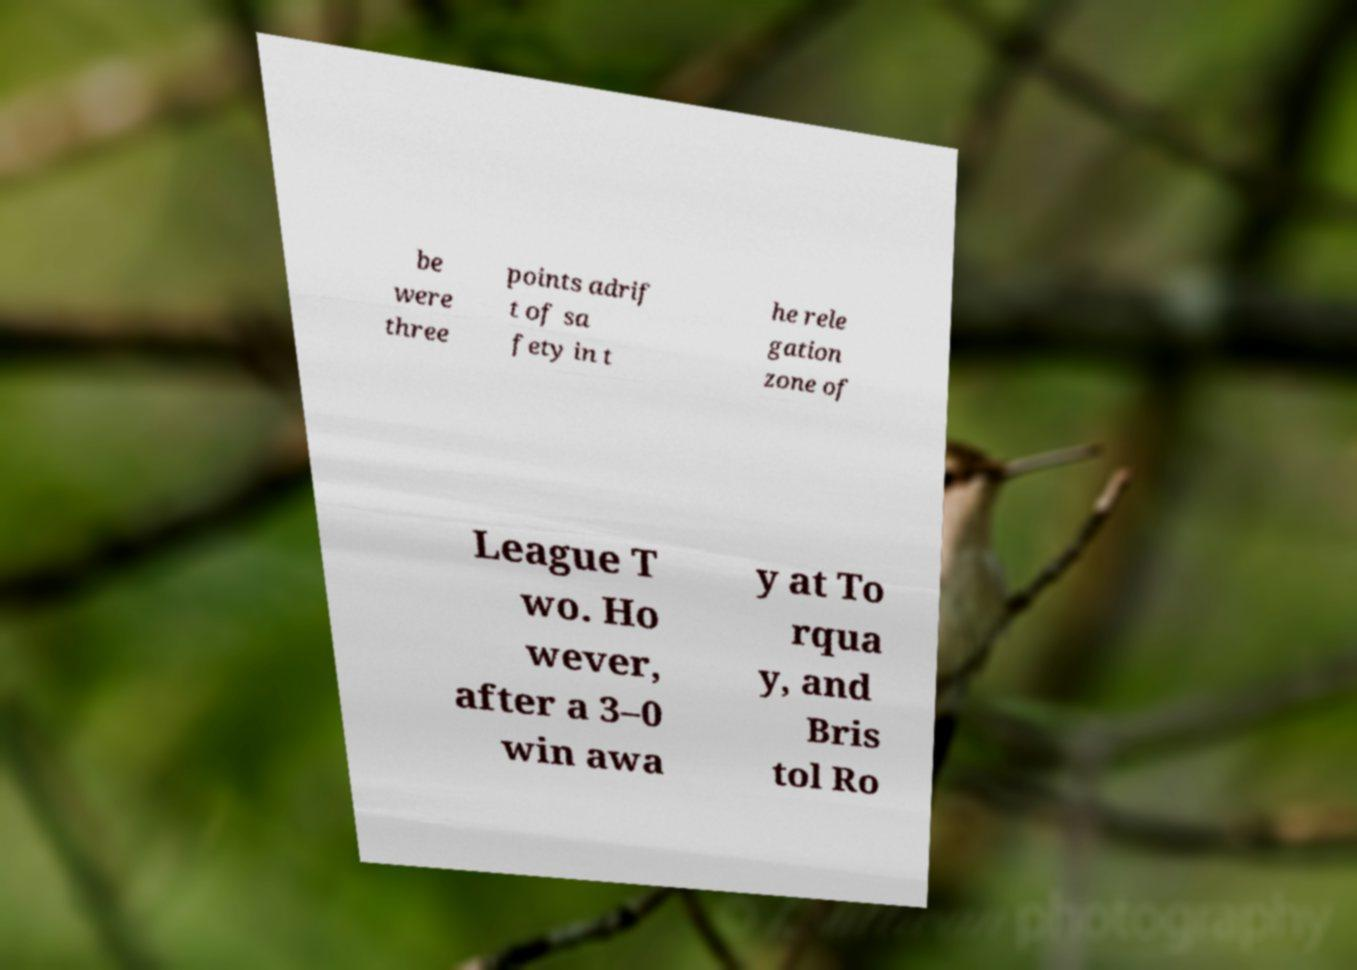Please read and relay the text visible in this image. What does it say? be were three points adrif t of sa fety in t he rele gation zone of League T wo. Ho wever, after a 3–0 win awa y at To rqua y, and Bris tol Ro 